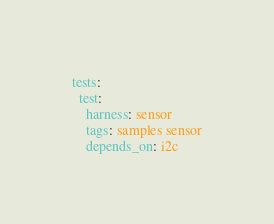<code> <loc_0><loc_0><loc_500><loc_500><_YAML_>tests:
  test:
    harness: sensor
    tags: samples sensor
    depends_on: i2c
</code> 